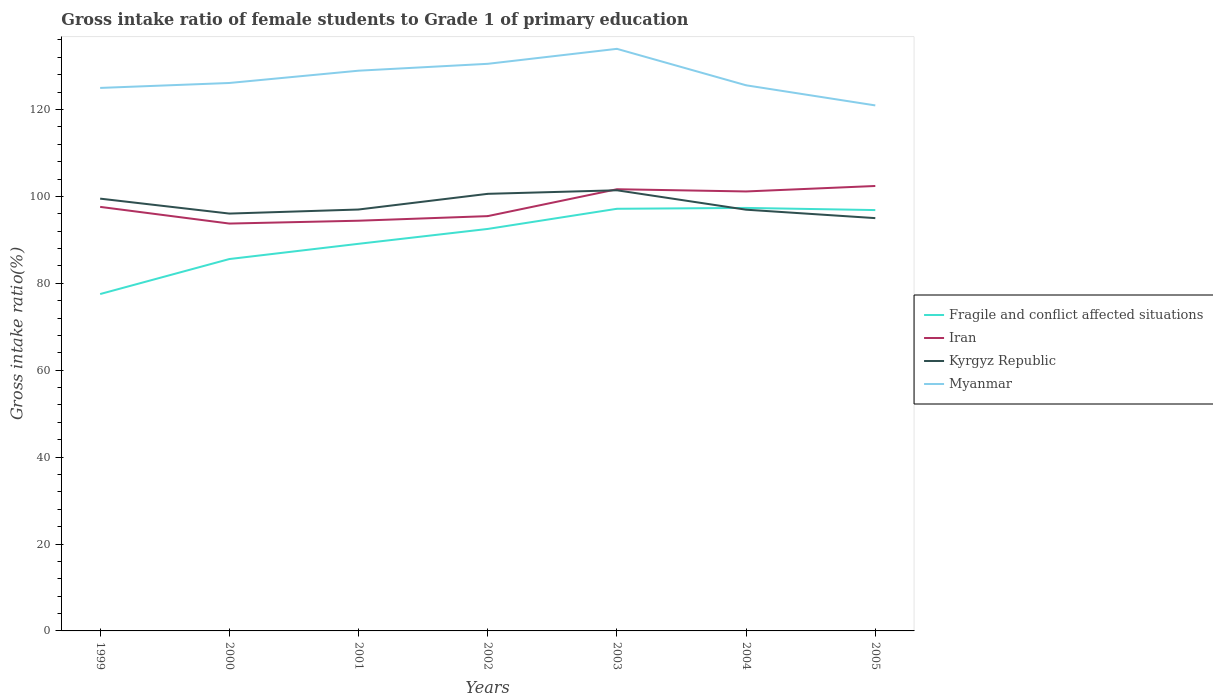Does the line corresponding to Fragile and conflict affected situations intersect with the line corresponding to Kyrgyz Republic?
Keep it short and to the point. Yes. Across all years, what is the maximum gross intake ratio in Kyrgyz Republic?
Offer a very short reply. 95. What is the total gross intake ratio in Iran in the graph?
Give a very brief answer. -1.06. What is the difference between the highest and the second highest gross intake ratio in Fragile and conflict affected situations?
Your answer should be very brief. 19.82. What is the difference between the highest and the lowest gross intake ratio in Kyrgyz Republic?
Your answer should be very brief. 3. How many lines are there?
Your answer should be very brief. 4. What is the difference between two consecutive major ticks on the Y-axis?
Make the answer very short. 20. Are the values on the major ticks of Y-axis written in scientific E-notation?
Give a very brief answer. No. Does the graph contain any zero values?
Your response must be concise. No. Does the graph contain grids?
Offer a terse response. No. What is the title of the graph?
Your answer should be compact. Gross intake ratio of female students to Grade 1 of primary education. What is the label or title of the Y-axis?
Keep it short and to the point. Gross intake ratio(%). What is the Gross intake ratio(%) of Fragile and conflict affected situations in 1999?
Provide a short and direct response. 77.53. What is the Gross intake ratio(%) of Iran in 1999?
Ensure brevity in your answer.  97.59. What is the Gross intake ratio(%) of Kyrgyz Republic in 1999?
Provide a succinct answer. 99.49. What is the Gross intake ratio(%) in Myanmar in 1999?
Offer a very short reply. 124.97. What is the Gross intake ratio(%) in Fragile and conflict affected situations in 2000?
Your answer should be compact. 85.58. What is the Gross intake ratio(%) of Iran in 2000?
Make the answer very short. 93.75. What is the Gross intake ratio(%) of Kyrgyz Republic in 2000?
Offer a very short reply. 96.05. What is the Gross intake ratio(%) in Myanmar in 2000?
Your response must be concise. 126.11. What is the Gross intake ratio(%) in Fragile and conflict affected situations in 2001?
Provide a short and direct response. 89.09. What is the Gross intake ratio(%) in Iran in 2001?
Offer a very short reply. 94.41. What is the Gross intake ratio(%) of Kyrgyz Republic in 2001?
Offer a very short reply. 96.98. What is the Gross intake ratio(%) of Myanmar in 2001?
Ensure brevity in your answer.  128.93. What is the Gross intake ratio(%) in Fragile and conflict affected situations in 2002?
Offer a very short reply. 92.51. What is the Gross intake ratio(%) of Iran in 2002?
Your answer should be very brief. 95.46. What is the Gross intake ratio(%) in Kyrgyz Republic in 2002?
Your response must be concise. 100.59. What is the Gross intake ratio(%) in Myanmar in 2002?
Provide a succinct answer. 130.52. What is the Gross intake ratio(%) of Fragile and conflict affected situations in 2003?
Your answer should be very brief. 97.15. What is the Gross intake ratio(%) of Iran in 2003?
Your response must be concise. 101.65. What is the Gross intake ratio(%) of Kyrgyz Republic in 2003?
Your answer should be compact. 101.41. What is the Gross intake ratio(%) in Myanmar in 2003?
Make the answer very short. 133.96. What is the Gross intake ratio(%) of Fragile and conflict affected situations in 2004?
Ensure brevity in your answer.  97.35. What is the Gross intake ratio(%) of Iran in 2004?
Provide a succinct answer. 101.14. What is the Gross intake ratio(%) of Kyrgyz Republic in 2004?
Offer a terse response. 96.94. What is the Gross intake ratio(%) of Myanmar in 2004?
Keep it short and to the point. 125.57. What is the Gross intake ratio(%) in Fragile and conflict affected situations in 2005?
Your answer should be very brief. 96.86. What is the Gross intake ratio(%) in Iran in 2005?
Provide a short and direct response. 102.4. What is the Gross intake ratio(%) in Kyrgyz Republic in 2005?
Ensure brevity in your answer.  95. What is the Gross intake ratio(%) of Myanmar in 2005?
Offer a terse response. 120.94. Across all years, what is the maximum Gross intake ratio(%) of Fragile and conflict affected situations?
Ensure brevity in your answer.  97.35. Across all years, what is the maximum Gross intake ratio(%) in Iran?
Provide a short and direct response. 102.4. Across all years, what is the maximum Gross intake ratio(%) of Kyrgyz Republic?
Offer a very short reply. 101.41. Across all years, what is the maximum Gross intake ratio(%) in Myanmar?
Give a very brief answer. 133.96. Across all years, what is the minimum Gross intake ratio(%) of Fragile and conflict affected situations?
Give a very brief answer. 77.53. Across all years, what is the minimum Gross intake ratio(%) in Iran?
Ensure brevity in your answer.  93.75. Across all years, what is the minimum Gross intake ratio(%) in Kyrgyz Republic?
Your answer should be compact. 95. Across all years, what is the minimum Gross intake ratio(%) in Myanmar?
Give a very brief answer. 120.94. What is the total Gross intake ratio(%) of Fragile and conflict affected situations in the graph?
Your answer should be compact. 636.08. What is the total Gross intake ratio(%) of Iran in the graph?
Give a very brief answer. 686.4. What is the total Gross intake ratio(%) of Kyrgyz Republic in the graph?
Keep it short and to the point. 686.47. What is the total Gross intake ratio(%) in Myanmar in the graph?
Make the answer very short. 890.99. What is the difference between the Gross intake ratio(%) in Fragile and conflict affected situations in 1999 and that in 2000?
Your response must be concise. -8.05. What is the difference between the Gross intake ratio(%) of Iran in 1999 and that in 2000?
Provide a succinct answer. 3.84. What is the difference between the Gross intake ratio(%) of Kyrgyz Republic in 1999 and that in 2000?
Your answer should be compact. 3.44. What is the difference between the Gross intake ratio(%) in Myanmar in 1999 and that in 2000?
Give a very brief answer. -1.14. What is the difference between the Gross intake ratio(%) in Fragile and conflict affected situations in 1999 and that in 2001?
Your answer should be compact. -11.56. What is the difference between the Gross intake ratio(%) of Iran in 1999 and that in 2001?
Your answer should be very brief. 3.18. What is the difference between the Gross intake ratio(%) in Kyrgyz Republic in 1999 and that in 2001?
Offer a terse response. 2.5. What is the difference between the Gross intake ratio(%) of Myanmar in 1999 and that in 2001?
Your answer should be very brief. -3.97. What is the difference between the Gross intake ratio(%) in Fragile and conflict affected situations in 1999 and that in 2002?
Your answer should be compact. -14.98. What is the difference between the Gross intake ratio(%) of Iran in 1999 and that in 2002?
Provide a short and direct response. 2.12. What is the difference between the Gross intake ratio(%) in Kyrgyz Republic in 1999 and that in 2002?
Provide a succinct answer. -1.11. What is the difference between the Gross intake ratio(%) in Myanmar in 1999 and that in 2002?
Make the answer very short. -5.55. What is the difference between the Gross intake ratio(%) of Fragile and conflict affected situations in 1999 and that in 2003?
Your response must be concise. -19.62. What is the difference between the Gross intake ratio(%) in Iran in 1999 and that in 2003?
Offer a terse response. -4.06. What is the difference between the Gross intake ratio(%) of Kyrgyz Republic in 1999 and that in 2003?
Your response must be concise. -1.92. What is the difference between the Gross intake ratio(%) in Myanmar in 1999 and that in 2003?
Your answer should be compact. -9. What is the difference between the Gross intake ratio(%) of Fragile and conflict affected situations in 1999 and that in 2004?
Give a very brief answer. -19.82. What is the difference between the Gross intake ratio(%) of Iran in 1999 and that in 2004?
Offer a very short reply. -3.55. What is the difference between the Gross intake ratio(%) in Kyrgyz Republic in 1999 and that in 2004?
Ensure brevity in your answer.  2.54. What is the difference between the Gross intake ratio(%) in Myanmar in 1999 and that in 2004?
Your response must be concise. -0.61. What is the difference between the Gross intake ratio(%) of Fragile and conflict affected situations in 1999 and that in 2005?
Offer a terse response. -19.32. What is the difference between the Gross intake ratio(%) of Iran in 1999 and that in 2005?
Ensure brevity in your answer.  -4.81. What is the difference between the Gross intake ratio(%) in Kyrgyz Republic in 1999 and that in 2005?
Give a very brief answer. 4.48. What is the difference between the Gross intake ratio(%) in Myanmar in 1999 and that in 2005?
Provide a short and direct response. 4.02. What is the difference between the Gross intake ratio(%) of Fragile and conflict affected situations in 2000 and that in 2001?
Give a very brief answer. -3.51. What is the difference between the Gross intake ratio(%) in Iran in 2000 and that in 2001?
Your answer should be very brief. -0.65. What is the difference between the Gross intake ratio(%) in Kyrgyz Republic in 2000 and that in 2001?
Your response must be concise. -0.93. What is the difference between the Gross intake ratio(%) of Myanmar in 2000 and that in 2001?
Provide a succinct answer. -2.83. What is the difference between the Gross intake ratio(%) of Fragile and conflict affected situations in 2000 and that in 2002?
Your response must be concise. -6.93. What is the difference between the Gross intake ratio(%) of Iran in 2000 and that in 2002?
Give a very brief answer. -1.71. What is the difference between the Gross intake ratio(%) of Kyrgyz Republic in 2000 and that in 2002?
Keep it short and to the point. -4.54. What is the difference between the Gross intake ratio(%) of Myanmar in 2000 and that in 2002?
Offer a very short reply. -4.41. What is the difference between the Gross intake ratio(%) in Fragile and conflict affected situations in 2000 and that in 2003?
Your answer should be very brief. -11.57. What is the difference between the Gross intake ratio(%) in Iran in 2000 and that in 2003?
Provide a succinct answer. -7.9. What is the difference between the Gross intake ratio(%) in Kyrgyz Republic in 2000 and that in 2003?
Offer a very short reply. -5.36. What is the difference between the Gross intake ratio(%) of Myanmar in 2000 and that in 2003?
Give a very brief answer. -7.86. What is the difference between the Gross intake ratio(%) of Fragile and conflict affected situations in 2000 and that in 2004?
Ensure brevity in your answer.  -11.77. What is the difference between the Gross intake ratio(%) of Iran in 2000 and that in 2004?
Offer a very short reply. -7.39. What is the difference between the Gross intake ratio(%) in Kyrgyz Republic in 2000 and that in 2004?
Make the answer very short. -0.89. What is the difference between the Gross intake ratio(%) in Myanmar in 2000 and that in 2004?
Provide a short and direct response. 0.53. What is the difference between the Gross intake ratio(%) in Fragile and conflict affected situations in 2000 and that in 2005?
Your response must be concise. -11.27. What is the difference between the Gross intake ratio(%) of Iran in 2000 and that in 2005?
Offer a very short reply. -8.65. What is the difference between the Gross intake ratio(%) in Kyrgyz Republic in 2000 and that in 2005?
Your answer should be very brief. 1.05. What is the difference between the Gross intake ratio(%) of Myanmar in 2000 and that in 2005?
Offer a terse response. 5.16. What is the difference between the Gross intake ratio(%) in Fragile and conflict affected situations in 2001 and that in 2002?
Offer a very short reply. -3.42. What is the difference between the Gross intake ratio(%) in Iran in 2001 and that in 2002?
Offer a terse response. -1.06. What is the difference between the Gross intake ratio(%) in Kyrgyz Republic in 2001 and that in 2002?
Make the answer very short. -3.61. What is the difference between the Gross intake ratio(%) of Myanmar in 2001 and that in 2002?
Offer a terse response. -1.58. What is the difference between the Gross intake ratio(%) in Fragile and conflict affected situations in 2001 and that in 2003?
Ensure brevity in your answer.  -8.06. What is the difference between the Gross intake ratio(%) of Iran in 2001 and that in 2003?
Your answer should be very brief. -7.24. What is the difference between the Gross intake ratio(%) of Kyrgyz Republic in 2001 and that in 2003?
Keep it short and to the point. -4.43. What is the difference between the Gross intake ratio(%) of Myanmar in 2001 and that in 2003?
Offer a very short reply. -5.03. What is the difference between the Gross intake ratio(%) in Fragile and conflict affected situations in 2001 and that in 2004?
Your answer should be very brief. -8.26. What is the difference between the Gross intake ratio(%) of Iran in 2001 and that in 2004?
Ensure brevity in your answer.  -6.74. What is the difference between the Gross intake ratio(%) of Kyrgyz Republic in 2001 and that in 2004?
Your response must be concise. 0.04. What is the difference between the Gross intake ratio(%) in Myanmar in 2001 and that in 2004?
Provide a short and direct response. 3.36. What is the difference between the Gross intake ratio(%) of Fragile and conflict affected situations in 2001 and that in 2005?
Your answer should be very brief. -7.76. What is the difference between the Gross intake ratio(%) of Iran in 2001 and that in 2005?
Ensure brevity in your answer.  -8. What is the difference between the Gross intake ratio(%) in Kyrgyz Republic in 2001 and that in 2005?
Your answer should be compact. 1.98. What is the difference between the Gross intake ratio(%) of Myanmar in 2001 and that in 2005?
Provide a succinct answer. 7.99. What is the difference between the Gross intake ratio(%) in Fragile and conflict affected situations in 2002 and that in 2003?
Your answer should be very brief. -4.64. What is the difference between the Gross intake ratio(%) of Iran in 2002 and that in 2003?
Offer a terse response. -6.19. What is the difference between the Gross intake ratio(%) in Kyrgyz Republic in 2002 and that in 2003?
Your response must be concise. -0.82. What is the difference between the Gross intake ratio(%) in Myanmar in 2002 and that in 2003?
Ensure brevity in your answer.  -3.45. What is the difference between the Gross intake ratio(%) in Fragile and conflict affected situations in 2002 and that in 2004?
Keep it short and to the point. -4.84. What is the difference between the Gross intake ratio(%) of Iran in 2002 and that in 2004?
Ensure brevity in your answer.  -5.68. What is the difference between the Gross intake ratio(%) of Kyrgyz Republic in 2002 and that in 2004?
Your answer should be compact. 3.65. What is the difference between the Gross intake ratio(%) in Myanmar in 2002 and that in 2004?
Provide a succinct answer. 4.94. What is the difference between the Gross intake ratio(%) of Fragile and conflict affected situations in 2002 and that in 2005?
Your answer should be compact. -4.34. What is the difference between the Gross intake ratio(%) of Iran in 2002 and that in 2005?
Ensure brevity in your answer.  -6.94. What is the difference between the Gross intake ratio(%) in Kyrgyz Republic in 2002 and that in 2005?
Offer a very short reply. 5.59. What is the difference between the Gross intake ratio(%) of Myanmar in 2002 and that in 2005?
Provide a succinct answer. 9.57. What is the difference between the Gross intake ratio(%) in Fragile and conflict affected situations in 2003 and that in 2004?
Give a very brief answer. -0.2. What is the difference between the Gross intake ratio(%) in Iran in 2003 and that in 2004?
Make the answer very short. 0.51. What is the difference between the Gross intake ratio(%) of Kyrgyz Republic in 2003 and that in 2004?
Make the answer very short. 4.47. What is the difference between the Gross intake ratio(%) of Myanmar in 2003 and that in 2004?
Keep it short and to the point. 8.39. What is the difference between the Gross intake ratio(%) of Fragile and conflict affected situations in 2003 and that in 2005?
Provide a succinct answer. 0.3. What is the difference between the Gross intake ratio(%) in Iran in 2003 and that in 2005?
Your answer should be very brief. -0.75. What is the difference between the Gross intake ratio(%) of Kyrgyz Republic in 2003 and that in 2005?
Your answer should be compact. 6.41. What is the difference between the Gross intake ratio(%) in Myanmar in 2003 and that in 2005?
Give a very brief answer. 13.02. What is the difference between the Gross intake ratio(%) in Fragile and conflict affected situations in 2004 and that in 2005?
Your answer should be compact. 0.49. What is the difference between the Gross intake ratio(%) of Iran in 2004 and that in 2005?
Your answer should be compact. -1.26. What is the difference between the Gross intake ratio(%) of Kyrgyz Republic in 2004 and that in 2005?
Provide a short and direct response. 1.94. What is the difference between the Gross intake ratio(%) of Myanmar in 2004 and that in 2005?
Keep it short and to the point. 4.63. What is the difference between the Gross intake ratio(%) in Fragile and conflict affected situations in 1999 and the Gross intake ratio(%) in Iran in 2000?
Your answer should be very brief. -16.22. What is the difference between the Gross intake ratio(%) of Fragile and conflict affected situations in 1999 and the Gross intake ratio(%) of Kyrgyz Republic in 2000?
Your answer should be very brief. -18.52. What is the difference between the Gross intake ratio(%) in Fragile and conflict affected situations in 1999 and the Gross intake ratio(%) in Myanmar in 2000?
Give a very brief answer. -48.57. What is the difference between the Gross intake ratio(%) of Iran in 1999 and the Gross intake ratio(%) of Kyrgyz Republic in 2000?
Provide a succinct answer. 1.54. What is the difference between the Gross intake ratio(%) in Iran in 1999 and the Gross intake ratio(%) in Myanmar in 2000?
Provide a succinct answer. -28.52. What is the difference between the Gross intake ratio(%) of Kyrgyz Republic in 1999 and the Gross intake ratio(%) of Myanmar in 2000?
Keep it short and to the point. -26.62. What is the difference between the Gross intake ratio(%) of Fragile and conflict affected situations in 1999 and the Gross intake ratio(%) of Iran in 2001?
Provide a short and direct response. -16.87. What is the difference between the Gross intake ratio(%) in Fragile and conflict affected situations in 1999 and the Gross intake ratio(%) in Kyrgyz Republic in 2001?
Keep it short and to the point. -19.45. What is the difference between the Gross intake ratio(%) in Fragile and conflict affected situations in 1999 and the Gross intake ratio(%) in Myanmar in 2001?
Make the answer very short. -51.4. What is the difference between the Gross intake ratio(%) in Iran in 1999 and the Gross intake ratio(%) in Kyrgyz Republic in 2001?
Provide a succinct answer. 0.6. What is the difference between the Gross intake ratio(%) of Iran in 1999 and the Gross intake ratio(%) of Myanmar in 2001?
Your answer should be very brief. -31.34. What is the difference between the Gross intake ratio(%) of Kyrgyz Republic in 1999 and the Gross intake ratio(%) of Myanmar in 2001?
Provide a short and direct response. -29.45. What is the difference between the Gross intake ratio(%) of Fragile and conflict affected situations in 1999 and the Gross intake ratio(%) of Iran in 2002?
Make the answer very short. -17.93. What is the difference between the Gross intake ratio(%) of Fragile and conflict affected situations in 1999 and the Gross intake ratio(%) of Kyrgyz Republic in 2002?
Your answer should be compact. -23.06. What is the difference between the Gross intake ratio(%) of Fragile and conflict affected situations in 1999 and the Gross intake ratio(%) of Myanmar in 2002?
Provide a succinct answer. -52.98. What is the difference between the Gross intake ratio(%) in Iran in 1999 and the Gross intake ratio(%) in Kyrgyz Republic in 2002?
Your response must be concise. -3. What is the difference between the Gross intake ratio(%) in Iran in 1999 and the Gross intake ratio(%) in Myanmar in 2002?
Provide a succinct answer. -32.93. What is the difference between the Gross intake ratio(%) of Kyrgyz Republic in 1999 and the Gross intake ratio(%) of Myanmar in 2002?
Provide a short and direct response. -31.03. What is the difference between the Gross intake ratio(%) in Fragile and conflict affected situations in 1999 and the Gross intake ratio(%) in Iran in 2003?
Keep it short and to the point. -24.12. What is the difference between the Gross intake ratio(%) in Fragile and conflict affected situations in 1999 and the Gross intake ratio(%) in Kyrgyz Republic in 2003?
Make the answer very short. -23.88. What is the difference between the Gross intake ratio(%) of Fragile and conflict affected situations in 1999 and the Gross intake ratio(%) of Myanmar in 2003?
Offer a terse response. -56.43. What is the difference between the Gross intake ratio(%) of Iran in 1999 and the Gross intake ratio(%) of Kyrgyz Republic in 2003?
Provide a short and direct response. -3.82. What is the difference between the Gross intake ratio(%) in Iran in 1999 and the Gross intake ratio(%) in Myanmar in 2003?
Give a very brief answer. -36.37. What is the difference between the Gross intake ratio(%) of Kyrgyz Republic in 1999 and the Gross intake ratio(%) of Myanmar in 2003?
Ensure brevity in your answer.  -34.48. What is the difference between the Gross intake ratio(%) in Fragile and conflict affected situations in 1999 and the Gross intake ratio(%) in Iran in 2004?
Make the answer very short. -23.61. What is the difference between the Gross intake ratio(%) of Fragile and conflict affected situations in 1999 and the Gross intake ratio(%) of Kyrgyz Republic in 2004?
Provide a short and direct response. -19.41. What is the difference between the Gross intake ratio(%) of Fragile and conflict affected situations in 1999 and the Gross intake ratio(%) of Myanmar in 2004?
Your response must be concise. -48.04. What is the difference between the Gross intake ratio(%) of Iran in 1999 and the Gross intake ratio(%) of Kyrgyz Republic in 2004?
Ensure brevity in your answer.  0.65. What is the difference between the Gross intake ratio(%) in Iran in 1999 and the Gross intake ratio(%) in Myanmar in 2004?
Offer a terse response. -27.98. What is the difference between the Gross intake ratio(%) of Kyrgyz Republic in 1999 and the Gross intake ratio(%) of Myanmar in 2004?
Your response must be concise. -26.09. What is the difference between the Gross intake ratio(%) of Fragile and conflict affected situations in 1999 and the Gross intake ratio(%) of Iran in 2005?
Your response must be concise. -24.87. What is the difference between the Gross intake ratio(%) of Fragile and conflict affected situations in 1999 and the Gross intake ratio(%) of Kyrgyz Republic in 2005?
Your answer should be very brief. -17.47. What is the difference between the Gross intake ratio(%) in Fragile and conflict affected situations in 1999 and the Gross intake ratio(%) in Myanmar in 2005?
Keep it short and to the point. -43.41. What is the difference between the Gross intake ratio(%) in Iran in 1999 and the Gross intake ratio(%) in Kyrgyz Republic in 2005?
Your answer should be very brief. 2.59. What is the difference between the Gross intake ratio(%) in Iran in 1999 and the Gross intake ratio(%) in Myanmar in 2005?
Offer a very short reply. -23.35. What is the difference between the Gross intake ratio(%) of Kyrgyz Republic in 1999 and the Gross intake ratio(%) of Myanmar in 2005?
Your answer should be compact. -21.46. What is the difference between the Gross intake ratio(%) in Fragile and conflict affected situations in 2000 and the Gross intake ratio(%) in Iran in 2001?
Give a very brief answer. -8.82. What is the difference between the Gross intake ratio(%) of Fragile and conflict affected situations in 2000 and the Gross intake ratio(%) of Kyrgyz Republic in 2001?
Your answer should be very brief. -11.4. What is the difference between the Gross intake ratio(%) of Fragile and conflict affected situations in 2000 and the Gross intake ratio(%) of Myanmar in 2001?
Keep it short and to the point. -43.35. What is the difference between the Gross intake ratio(%) in Iran in 2000 and the Gross intake ratio(%) in Kyrgyz Republic in 2001?
Give a very brief answer. -3.23. What is the difference between the Gross intake ratio(%) of Iran in 2000 and the Gross intake ratio(%) of Myanmar in 2001?
Make the answer very short. -35.18. What is the difference between the Gross intake ratio(%) of Kyrgyz Republic in 2000 and the Gross intake ratio(%) of Myanmar in 2001?
Make the answer very short. -32.88. What is the difference between the Gross intake ratio(%) in Fragile and conflict affected situations in 2000 and the Gross intake ratio(%) in Iran in 2002?
Offer a very short reply. -9.88. What is the difference between the Gross intake ratio(%) of Fragile and conflict affected situations in 2000 and the Gross intake ratio(%) of Kyrgyz Republic in 2002?
Offer a very short reply. -15.01. What is the difference between the Gross intake ratio(%) of Fragile and conflict affected situations in 2000 and the Gross intake ratio(%) of Myanmar in 2002?
Your answer should be compact. -44.93. What is the difference between the Gross intake ratio(%) in Iran in 2000 and the Gross intake ratio(%) in Kyrgyz Republic in 2002?
Your answer should be compact. -6.84. What is the difference between the Gross intake ratio(%) of Iran in 2000 and the Gross intake ratio(%) of Myanmar in 2002?
Keep it short and to the point. -36.76. What is the difference between the Gross intake ratio(%) of Kyrgyz Republic in 2000 and the Gross intake ratio(%) of Myanmar in 2002?
Make the answer very short. -34.47. What is the difference between the Gross intake ratio(%) of Fragile and conflict affected situations in 2000 and the Gross intake ratio(%) of Iran in 2003?
Your answer should be compact. -16.07. What is the difference between the Gross intake ratio(%) in Fragile and conflict affected situations in 2000 and the Gross intake ratio(%) in Kyrgyz Republic in 2003?
Provide a short and direct response. -15.83. What is the difference between the Gross intake ratio(%) in Fragile and conflict affected situations in 2000 and the Gross intake ratio(%) in Myanmar in 2003?
Offer a terse response. -48.38. What is the difference between the Gross intake ratio(%) in Iran in 2000 and the Gross intake ratio(%) in Kyrgyz Republic in 2003?
Give a very brief answer. -7.66. What is the difference between the Gross intake ratio(%) in Iran in 2000 and the Gross intake ratio(%) in Myanmar in 2003?
Make the answer very short. -40.21. What is the difference between the Gross intake ratio(%) of Kyrgyz Republic in 2000 and the Gross intake ratio(%) of Myanmar in 2003?
Keep it short and to the point. -37.91. What is the difference between the Gross intake ratio(%) of Fragile and conflict affected situations in 2000 and the Gross intake ratio(%) of Iran in 2004?
Your response must be concise. -15.56. What is the difference between the Gross intake ratio(%) in Fragile and conflict affected situations in 2000 and the Gross intake ratio(%) in Kyrgyz Republic in 2004?
Keep it short and to the point. -11.36. What is the difference between the Gross intake ratio(%) in Fragile and conflict affected situations in 2000 and the Gross intake ratio(%) in Myanmar in 2004?
Ensure brevity in your answer.  -39.99. What is the difference between the Gross intake ratio(%) of Iran in 2000 and the Gross intake ratio(%) of Kyrgyz Republic in 2004?
Keep it short and to the point. -3.19. What is the difference between the Gross intake ratio(%) of Iran in 2000 and the Gross intake ratio(%) of Myanmar in 2004?
Offer a very short reply. -31.82. What is the difference between the Gross intake ratio(%) in Kyrgyz Republic in 2000 and the Gross intake ratio(%) in Myanmar in 2004?
Your response must be concise. -29.52. What is the difference between the Gross intake ratio(%) in Fragile and conflict affected situations in 2000 and the Gross intake ratio(%) in Iran in 2005?
Make the answer very short. -16.82. What is the difference between the Gross intake ratio(%) in Fragile and conflict affected situations in 2000 and the Gross intake ratio(%) in Kyrgyz Republic in 2005?
Your answer should be very brief. -9.42. What is the difference between the Gross intake ratio(%) of Fragile and conflict affected situations in 2000 and the Gross intake ratio(%) of Myanmar in 2005?
Your answer should be very brief. -35.36. What is the difference between the Gross intake ratio(%) of Iran in 2000 and the Gross intake ratio(%) of Kyrgyz Republic in 2005?
Provide a short and direct response. -1.25. What is the difference between the Gross intake ratio(%) of Iran in 2000 and the Gross intake ratio(%) of Myanmar in 2005?
Your response must be concise. -27.19. What is the difference between the Gross intake ratio(%) of Kyrgyz Republic in 2000 and the Gross intake ratio(%) of Myanmar in 2005?
Offer a terse response. -24.89. What is the difference between the Gross intake ratio(%) in Fragile and conflict affected situations in 2001 and the Gross intake ratio(%) in Iran in 2002?
Provide a short and direct response. -6.37. What is the difference between the Gross intake ratio(%) of Fragile and conflict affected situations in 2001 and the Gross intake ratio(%) of Kyrgyz Republic in 2002?
Offer a terse response. -11.5. What is the difference between the Gross intake ratio(%) in Fragile and conflict affected situations in 2001 and the Gross intake ratio(%) in Myanmar in 2002?
Give a very brief answer. -41.42. What is the difference between the Gross intake ratio(%) of Iran in 2001 and the Gross intake ratio(%) of Kyrgyz Republic in 2002?
Make the answer very short. -6.19. What is the difference between the Gross intake ratio(%) in Iran in 2001 and the Gross intake ratio(%) in Myanmar in 2002?
Keep it short and to the point. -36.11. What is the difference between the Gross intake ratio(%) in Kyrgyz Republic in 2001 and the Gross intake ratio(%) in Myanmar in 2002?
Make the answer very short. -33.53. What is the difference between the Gross intake ratio(%) in Fragile and conflict affected situations in 2001 and the Gross intake ratio(%) in Iran in 2003?
Give a very brief answer. -12.56. What is the difference between the Gross intake ratio(%) in Fragile and conflict affected situations in 2001 and the Gross intake ratio(%) in Kyrgyz Republic in 2003?
Your answer should be very brief. -12.32. What is the difference between the Gross intake ratio(%) in Fragile and conflict affected situations in 2001 and the Gross intake ratio(%) in Myanmar in 2003?
Your answer should be very brief. -44.87. What is the difference between the Gross intake ratio(%) of Iran in 2001 and the Gross intake ratio(%) of Kyrgyz Republic in 2003?
Make the answer very short. -7.01. What is the difference between the Gross intake ratio(%) in Iran in 2001 and the Gross intake ratio(%) in Myanmar in 2003?
Offer a terse response. -39.56. What is the difference between the Gross intake ratio(%) of Kyrgyz Republic in 2001 and the Gross intake ratio(%) of Myanmar in 2003?
Make the answer very short. -36.98. What is the difference between the Gross intake ratio(%) of Fragile and conflict affected situations in 2001 and the Gross intake ratio(%) of Iran in 2004?
Your answer should be very brief. -12.05. What is the difference between the Gross intake ratio(%) in Fragile and conflict affected situations in 2001 and the Gross intake ratio(%) in Kyrgyz Republic in 2004?
Offer a very short reply. -7.85. What is the difference between the Gross intake ratio(%) of Fragile and conflict affected situations in 2001 and the Gross intake ratio(%) of Myanmar in 2004?
Make the answer very short. -36.48. What is the difference between the Gross intake ratio(%) in Iran in 2001 and the Gross intake ratio(%) in Kyrgyz Republic in 2004?
Give a very brief answer. -2.54. What is the difference between the Gross intake ratio(%) in Iran in 2001 and the Gross intake ratio(%) in Myanmar in 2004?
Provide a succinct answer. -31.17. What is the difference between the Gross intake ratio(%) in Kyrgyz Republic in 2001 and the Gross intake ratio(%) in Myanmar in 2004?
Offer a terse response. -28.59. What is the difference between the Gross intake ratio(%) in Fragile and conflict affected situations in 2001 and the Gross intake ratio(%) in Iran in 2005?
Make the answer very short. -13.31. What is the difference between the Gross intake ratio(%) in Fragile and conflict affected situations in 2001 and the Gross intake ratio(%) in Kyrgyz Republic in 2005?
Your answer should be compact. -5.91. What is the difference between the Gross intake ratio(%) of Fragile and conflict affected situations in 2001 and the Gross intake ratio(%) of Myanmar in 2005?
Make the answer very short. -31.85. What is the difference between the Gross intake ratio(%) in Iran in 2001 and the Gross intake ratio(%) in Kyrgyz Republic in 2005?
Make the answer very short. -0.6. What is the difference between the Gross intake ratio(%) in Iran in 2001 and the Gross intake ratio(%) in Myanmar in 2005?
Provide a short and direct response. -26.54. What is the difference between the Gross intake ratio(%) in Kyrgyz Republic in 2001 and the Gross intake ratio(%) in Myanmar in 2005?
Give a very brief answer. -23.96. What is the difference between the Gross intake ratio(%) of Fragile and conflict affected situations in 2002 and the Gross intake ratio(%) of Iran in 2003?
Your answer should be very brief. -9.14. What is the difference between the Gross intake ratio(%) of Fragile and conflict affected situations in 2002 and the Gross intake ratio(%) of Kyrgyz Republic in 2003?
Offer a terse response. -8.9. What is the difference between the Gross intake ratio(%) in Fragile and conflict affected situations in 2002 and the Gross intake ratio(%) in Myanmar in 2003?
Provide a short and direct response. -41.45. What is the difference between the Gross intake ratio(%) in Iran in 2002 and the Gross intake ratio(%) in Kyrgyz Republic in 2003?
Keep it short and to the point. -5.95. What is the difference between the Gross intake ratio(%) of Iran in 2002 and the Gross intake ratio(%) of Myanmar in 2003?
Ensure brevity in your answer.  -38.5. What is the difference between the Gross intake ratio(%) of Kyrgyz Republic in 2002 and the Gross intake ratio(%) of Myanmar in 2003?
Provide a short and direct response. -33.37. What is the difference between the Gross intake ratio(%) in Fragile and conflict affected situations in 2002 and the Gross intake ratio(%) in Iran in 2004?
Give a very brief answer. -8.63. What is the difference between the Gross intake ratio(%) of Fragile and conflict affected situations in 2002 and the Gross intake ratio(%) of Kyrgyz Republic in 2004?
Keep it short and to the point. -4.43. What is the difference between the Gross intake ratio(%) in Fragile and conflict affected situations in 2002 and the Gross intake ratio(%) in Myanmar in 2004?
Keep it short and to the point. -33.06. What is the difference between the Gross intake ratio(%) in Iran in 2002 and the Gross intake ratio(%) in Kyrgyz Republic in 2004?
Your answer should be compact. -1.48. What is the difference between the Gross intake ratio(%) of Iran in 2002 and the Gross intake ratio(%) of Myanmar in 2004?
Provide a succinct answer. -30.11. What is the difference between the Gross intake ratio(%) of Kyrgyz Republic in 2002 and the Gross intake ratio(%) of Myanmar in 2004?
Keep it short and to the point. -24.98. What is the difference between the Gross intake ratio(%) in Fragile and conflict affected situations in 2002 and the Gross intake ratio(%) in Iran in 2005?
Provide a succinct answer. -9.89. What is the difference between the Gross intake ratio(%) of Fragile and conflict affected situations in 2002 and the Gross intake ratio(%) of Kyrgyz Republic in 2005?
Give a very brief answer. -2.49. What is the difference between the Gross intake ratio(%) of Fragile and conflict affected situations in 2002 and the Gross intake ratio(%) of Myanmar in 2005?
Your answer should be very brief. -28.43. What is the difference between the Gross intake ratio(%) of Iran in 2002 and the Gross intake ratio(%) of Kyrgyz Republic in 2005?
Your answer should be very brief. 0.46. What is the difference between the Gross intake ratio(%) in Iran in 2002 and the Gross intake ratio(%) in Myanmar in 2005?
Ensure brevity in your answer.  -25.48. What is the difference between the Gross intake ratio(%) in Kyrgyz Republic in 2002 and the Gross intake ratio(%) in Myanmar in 2005?
Your response must be concise. -20.35. What is the difference between the Gross intake ratio(%) of Fragile and conflict affected situations in 2003 and the Gross intake ratio(%) of Iran in 2004?
Your response must be concise. -3.99. What is the difference between the Gross intake ratio(%) in Fragile and conflict affected situations in 2003 and the Gross intake ratio(%) in Kyrgyz Republic in 2004?
Provide a succinct answer. 0.21. What is the difference between the Gross intake ratio(%) of Fragile and conflict affected situations in 2003 and the Gross intake ratio(%) of Myanmar in 2004?
Your answer should be compact. -28.42. What is the difference between the Gross intake ratio(%) in Iran in 2003 and the Gross intake ratio(%) in Kyrgyz Republic in 2004?
Make the answer very short. 4.71. What is the difference between the Gross intake ratio(%) in Iran in 2003 and the Gross intake ratio(%) in Myanmar in 2004?
Keep it short and to the point. -23.92. What is the difference between the Gross intake ratio(%) of Kyrgyz Republic in 2003 and the Gross intake ratio(%) of Myanmar in 2004?
Your answer should be very brief. -24.16. What is the difference between the Gross intake ratio(%) in Fragile and conflict affected situations in 2003 and the Gross intake ratio(%) in Iran in 2005?
Make the answer very short. -5.25. What is the difference between the Gross intake ratio(%) of Fragile and conflict affected situations in 2003 and the Gross intake ratio(%) of Kyrgyz Republic in 2005?
Offer a very short reply. 2.15. What is the difference between the Gross intake ratio(%) in Fragile and conflict affected situations in 2003 and the Gross intake ratio(%) in Myanmar in 2005?
Your response must be concise. -23.79. What is the difference between the Gross intake ratio(%) of Iran in 2003 and the Gross intake ratio(%) of Kyrgyz Republic in 2005?
Your response must be concise. 6.65. What is the difference between the Gross intake ratio(%) of Iran in 2003 and the Gross intake ratio(%) of Myanmar in 2005?
Ensure brevity in your answer.  -19.29. What is the difference between the Gross intake ratio(%) in Kyrgyz Republic in 2003 and the Gross intake ratio(%) in Myanmar in 2005?
Offer a terse response. -19.53. What is the difference between the Gross intake ratio(%) in Fragile and conflict affected situations in 2004 and the Gross intake ratio(%) in Iran in 2005?
Your answer should be compact. -5.05. What is the difference between the Gross intake ratio(%) in Fragile and conflict affected situations in 2004 and the Gross intake ratio(%) in Kyrgyz Republic in 2005?
Your answer should be compact. 2.35. What is the difference between the Gross intake ratio(%) in Fragile and conflict affected situations in 2004 and the Gross intake ratio(%) in Myanmar in 2005?
Provide a succinct answer. -23.59. What is the difference between the Gross intake ratio(%) in Iran in 2004 and the Gross intake ratio(%) in Kyrgyz Republic in 2005?
Give a very brief answer. 6.14. What is the difference between the Gross intake ratio(%) of Iran in 2004 and the Gross intake ratio(%) of Myanmar in 2005?
Keep it short and to the point. -19.8. What is the difference between the Gross intake ratio(%) of Kyrgyz Republic in 2004 and the Gross intake ratio(%) of Myanmar in 2005?
Offer a very short reply. -24. What is the average Gross intake ratio(%) in Fragile and conflict affected situations per year?
Offer a very short reply. 90.87. What is the average Gross intake ratio(%) of Iran per year?
Provide a short and direct response. 98.06. What is the average Gross intake ratio(%) of Kyrgyz Republic per year?
Your response must be concise. 98.07. What is the average Gross intake ratio(%) of Myanmar per year?
Provide a short and direct response. 127.28. In the year 1999, what is the difference between the Gross intake ratio(%) in Fragile and conflict affected situations and Gross intake ratio(%) in Iran?
Give a very brief answer. -20.06. In the year 1999, what is the difference between the Gross intake ratio(%) of Fragile and conflict affected situations and Gross intake ratio(%) of Kyrgyz Republic?
Your answer should be compact. -21.95. In the year 1999, what is the difference between the Gross intake ratio(%) in Fragile and conflict affected situations and Gross intake ratio(%) in Myanmar?
Offer a terse response. -47.43. In the year 1999, what is the difference between the Gross intake ratio(%) of Iran and Gross intake ratio(%) of Kyrgyz Republic?
Provide a succinct answer. -1.9. In the year 1999, what is the difference between the Gross intake ratio(%) in Iran and Gross intake ratio(%) in Myanmar?
Keep it short and to the point. -27.38. In the year 1999, what is the difference between the Gross intake ratio(%) in Kyrgyz Republic and Gross intake ratio(%) in Myanmar?
Your answer should be very brief. -25.48. In the year 2000, what is the difference between the Gross intake ratio(%) of Fragile and conflict affected situations and Gross intake ratio(%) of Iran?
Provide a succinct answer. -8.17. In the year 2000, what is the difference between the Gross intake ratio(%) in Fragile and conflict affected situations and Gross intake ratio(%) in Kyrgyz Republic?
Make the answer very short. -10.47. In the year 2000, what is the difference between the Gross intake ratio(%) in Fragile and conflict affected situations and Gross intake ratio(%) in Myanmar?
Keep it short and to the point. -40.52. In the year 2000, what is the difference between the Gross intake ratio(%) of Iran and Gross intake ratio(%) of Kyrgyz Republic?
Your answer should be compact. -2.3. In the year 2000, what is the difference between the Gross intake ratio(%) in Iran and Gross intake ratio(%) in Myanmar?
Your answer should be very brief. -32.35. In the year 2000, what is the difference between the Gross intake ratio(%) in Kyrgyz Republic and Gross intake ratio(%) in Myanmar?
Offer a terse response. -30.05. In the year 2001, what is the difference between the Gross intake ratio(%) in Fragile and conflict affected situations and Gross intake ratio(%) in Iran?
Give a very brief answer. -5.31. In the year 2001, what is the difference between the Gross intake ratio(%) in Fragile and conflict affected situations and Gross intake ratio(%) in Kyrgyz Republic?
Provide a short and direct response. -7.89. In the year 2001, what is the difference between the Gross intake ratio(%) in Fragile and conflict affected situations and Gross intake ratio(%) in Myanmar?
Provide a short and direct response. -39.84. In the year 2001, what is the difference between the Gross intake ratio(%) in Iran and Gross intake ratio(%) in Kyrgyz Republic?
Offer a very short reply. -2.58. In the year 2001, what is the difference between the Gross intake ratio(%) in Iran and Gross intake ratio(%) in Myanmar?
Keep it short and to the point. -34.53. In the year 2001, what is the difference between the Gross intake ratio(%) of Kyrgyz Republic and Gross intake ratio(%) of Myanmar?
Your answer should be very brief. -31.95. In the year 2002, what is the difference between the Gross intake ratio(%) in Fragile and conflict affected situations and Gross intake ratio(%) in Iran?
Make the answer very short. -2.95. In the year 2002, what is the difference between the Gross intake ratio(%) in Fragile and conflict affected situations and Gross intake ratio(%) in Kyrgyz Republic?
Offer a terse response. -8.08. In the year 2002, what is the difference between the Gross intake ratio(%) in Fragile and conflict affected situations and Gross intake ratio(%) in Myanmar?
Give a very brief answer. -38. In the year 2002, what is the difference between the Gross intake ratio(%) in Iran and Gross intake ratio(%) in Kyrgyz Republic?
Your answer should be very brief. -5.13. In the year 2002, what is the difference between the Gross intake ratio(%) in Iran and Gross intake ratio(%) in Myanmar?
Ensure brevity in your answer.  -35.05. In the year 2002, what is the difference between the Gross intake ratio(%) in Kyrgyz Republic and Gross intake ratio(%) in Myanmar?
Keep it short and to the point. -29.92. In the year 2003, what is the difference between the Gross intake ratio(%) in Fragile and conflict affected situations and Gross intake ratio(%) in Iran?
Provide a succinct answer. -4.5. In the year 2003, what is the difference between the Gross intake ratio(%) in Fragile and conflict affected situations and Gross intake ratio(%) in Kyrgyz Republic?
Make the answer very short. -4.26. In the year 2003, what is the difference between the Gross intake ratio(%) in Fragile and conflict affected situations and Gross intake ratio(%) in Myanmar?
Give a very brief answer. -36.81. In the year 2003, what is the difference between the Gross intake ratio(%) of Iran and Gross intake ratio(%) of Kyrgyz Republic?
Your answer should be compact. 0.24. In the year 2003, what is the difference between the Gross intake ratio(%) in Iran and Gross intake ratio(%) in Myanmar?
Make the answer very short. -32.31. In the year 2003, what is the difference between the Gross intake ratio(%) in Kyrgyz Republic and Gross intake ratio(%) in Myanmar?
Provide a succinct answer. -32.55. In the year 2004, what is the difference between the Gross intake ratio(%) in Fragile and conflict affected situations and Gross intake ratio(%) in Iran?
Keep it short and to the point. -3.79. In the year 2004, what is the difference between the Gross intake ratio(%) of Fragile and conflict affected situations and Gross intake ratio(%) of Kyrgyz Republic?
Your answer should be compact. 0.41. In the year 2004, what is the difference between the Gross intake ratio(%) in Fragile and conflict affected situations and Gross intake ratio(%) in Myanmar?
Offer a very short reply. -28.22. In the year 2004, what is the difference between the Gross intake ratio(%) in Iran and Gross intake ratio(%) in Kyrgyz Republic?
Give a very brief answer. 4.2. In the year 2004, what is the difference between the Gross intake ratio(%) of Iran and Gross intake ratio(%) of Myanmar?
Provide a succinct answer. -24.43. In the year 2004, what is the difference between the Gross intake ratio(%) in Kyrgyz Republic and Gross intake ratio(%) in Myanmar?
Keep it short and to the point. -28.63. In the year 2005, what is the difference between the Gross intake ratio(%) of Fragile and conflict affected situations and Gross intake ratio(%) of Iran?
Give a very brief answer. -5.54. In the year 2005, what is the difference between the Gross intake ratio(%) of Fragile and conflict affected situations and Gross intake ratio(%) of Kyrgyz Republic?
Your response must be concise. 1.85. In the year 2005, what is the difference between the Gross intake ratio(%) in Fragile and conflict affected situations and Gross intake ratio(%) in Myanmar?
Make the answer very short. -24.09. In the year 2005, what is the difference between the Gross intake ratio(%) of Iran and Gross intake ratio(%) of Kyrgyz Republic?
Your response must be concise. 7.4. In the year 2005, what is the difference between the Gross intake ratio(%) of Iran and Gross intake ratio(%) of Myanmar?
Provide a short and direct response. -18.54. In the year 2005, what is the difference between the Gross intake ratio(%) of Kyrgyz Republic and Gross intake ratio(%) of Myanmar?
Offer a very short reply. -25.94. What is the ratio of the Gross intake ratio(%) in Fragile and conflict affected situations in 1999 to that in 2000?
Offer a very short reply. 0.91. What is the ratio of the Gross intake ratio(%) in Iran in 1999 to that in 2000?
Provide a short and direct response. 1.04. What is the ratio of the Gross intake ratio(%) of Kyrgyz Republic in 1999 to that in 2000?
Your answer should be very brief. 1.04. What is the ratio of the Gross intake ratio(%) of Fragile and conflict affected situations in 1999 to that in 2001?
Ensure brevity in your answer.  0.87. What is the ratio of the Gross intake ratio(%) in Iran in 1999 to that in 2001?
Give a very brief answer. 1.03. What is the ratio of the Gross intake ratio(%) in Kyrgyz Republic in 1999 to that in 2001?
Give a very brief answer. 1.03. What is the ratio of the Gross intake ratio(%) of Myanmar in 1999 to that in 2001?
Provide a succinct answer. 0.97. What is the ratio of the Gross intake ratio(%) of Fragile and conflict affected situations in 1999 to that in 2002?
Keep it short and to the point. 0.84. What is the ratio of the Gross intake ratio(%) of Iran in 1999 to that in 2002?
Provide a succinct answer. 1.02. What is the ratio of the Gross intake ratio(%) of Myanmar in 1999 to that in 2002?
Your response must be concise. 0.96. What is the ratio of the Gross intake ratio(%) in Fragile and conflict affected situations in 1999 to that in 2003?
Your answer should be very brief. 0.8. What is the ratio of the Gross intake ratio(%) of Iran in 1999 to that in 2003?
Make the answer very short. 0.96. What is the ratio of the Gross intake ratio(%) of Kyrgyz Republic in 1999 to that in 2003?
Provide a succinct answer. 0.98. What is the ratio of the Gross intake ratio(%) in Myanmar in 1999 to that in 2003?
Your response must be concise. 0.93. What is the ratio of the Gross intake ratio(%) in Fragile and conflict affected situations in 1999 to that in 2004?
Provide a short and direct response. 0.8. What is the ratio of the Gross intake ratio(%) of Iran in 1999 to that in 2004?
Offer a terse response. 0.96. What is the ratio of the Gross intake ratio(%) in Kyrgyz Republic in 1999 to that in 2004?
Make the answer very short. 1.03. What is the ratio of the Gross intake ratio(%) in Fragile and conflict affected situations in 1999 to that in 2005?
Offer a very short reply. 0.8. What is the ratio of the Gross intake ratio(%) of Iran in 1999 to that in 2005?
Keep it short and to the point. 0.95. What is the ratio of the Gross intake ratio(%) of Kyrgyz Republic in 1999 to that in 2005?
Provide a succinct answer. 1.05. What is the ratio of the Gross intake ratio(%) of Fragile and conflict affected situations in 2000 to that in 2001?
Ensure brevity in your answer.  0.96. What is the ratio of the Gross intake ratio(%) of Iran in 2000 to that in 2001?
Offer a very short reply. 0.99. What is the ratio of the Gross intake ratio(%) in Myanmar in 2000 to that in 2001?
Give a very brief answer. 0.98. What is the ratio of the Gross intake ratio(%) of Fragile and conflict affected situations in 2000 to that in 2002?
Ensure brevity in your answer.  0.93. What is the ratio of the Gross intake ratio(%) in Iran in 2000 to that in 2002?
Offer a terse response. 0.98. What is the ratio of the Gross intake ratio(%) of Kyrgyz Republic in 2000 to that in 2002?
Offer a very short reply. 0.95. What is the ratio of the Gross intake ratio(%) in Myanmar in 2000 to that in 2002?
Your answer should be very brief. 0.97. What is the ratio of the Gross intake ratio(%) of Fragile and conflict affected situations in 2000 to that in 2003?
Keep it short and to the point. 0.88. What is the ratio of the Gross intake ratio(%) of Iran in 2000 to that in 2003?
Give a very brief answer. 0.92. What is the ratio of the Gross intake ratio(%) in Kyrgyz Republic in 2000 to that in 2003?
Ensure brevity in your answer.  0.95. What is the ratio of the Gross intake ratio(%) in Myanmar in 2000 to that in 2003?
Give a very brief answer. 0.94. What is the ratio of the Gross intake ratio(%) of Fragile and conflict affected situations in 2000 to that in 2004?
Give a very brief answer. 0.88. What is the ratio of the Gross intake ratio(%) of Iran in 2000 to that in 2004?
Provide a short and direct response. 0.93. What is the ratio of the Gross intake ratio(%) in Kyrgyz Republic in 2000 to that in 2004?
Provide a succinct answer. 0.99. What is the ratio of the Gross intake ratio(%) in Fragile and conflict affected situations in 2000 to that in 2005?
Give a very brief answer. 0.88. What is the ratio of the Gross intake ratio(%) of Iran in 2000 to that in 2005?
Your answer should be very brief. 0.92. What is the ratio of the Gross intake ratio(%) of Kyrgyz Republic in 2000 to that in 2005?
Your answer should be very brief. 1.01. What is the ratio of the Gross intake ratio(%) in Myanmar in 2000 to that in 2005?
Your response must be concise. 1.04. What is the ratio of the Gross intake ratio(%) in Iran in 2001 to that in 2002?
Your response must be concise. 0.99. What is the ratio of the Gross intake ratio(%) of Kyrgyz Republic in 2001 to that in 2002?
Provide a succinct answer. 0.96. What is the ratio of the Gross intake ratio(%) of Myanmar in 2001 to that in 2002?
Your answer should be compact. 0.99. What is the ratio of the Gross intake ratio(%) of Fragile and conflict affected situations in 2001 to that in 2003?
Keep it short and to the point. 0.92. What is the ratio of the Gross intake ratio(%) of Iran in 2001 to that in 2003?
Provide a succinct answer. 0.93. What is the ratio of the Gross intake ratio(%) of Kyrgyz Republic in 2001 to that in 2003?
Provide a succinct answer. 0.96. What is the ratio of the Gross intake ratio(%) in Myanmar in 2001 to that in 2003?
Your answer should be very brief. 0.96. What is the ratio of the Gross intake ratio(%) in Fragile and conflict affected situations in 2001 to that in 2004?
Keep it short and to the point. 0.92. What is the ratio of the Gross intake ratio(%) in Iran in 2001 to that in 2004?
Keep it short and to the point. 0.93. What is the ratio of the Gross intake ratio(%) in Kyrgyz Republic in 2001 to that in 2004?
Offer a terse response. 1. What is the ratio of the Gross intake ratio(%) in Myanmar in 2001 to that in 2004?
Provide a succinct answer. 1.03. What is the ratio of the Gross intake ratio(%) in Fragile and conflict affected situations in 2001 to that in 2005?
Make the answer very short. 0.92. What is the ratio of the Gross intake ratio(%) of Iran in 2001 to that in 2005?
Offer a very short reply. 0.92. What is the ratio of the Gross intake ratio(%) in Kyrgyz Republic in 2001 to that in 2005?
Give a very brief answer. 1.02. What is the ratio of the Gross intake ratio(%) in Myanmar in 2001 to that in 2005?
Offer a terse response. 1.07. What is the ratio of the Gross intake ratio(%) in Fragile and conflict affected situations in 2002 to that in 2003?
Offer a very short reply. 0.95. What is the ratio of the Gross intake ratio(%) in Iran in 2002 to that in 2003?
Keep it short and to the point. 0.94. What is the ratio of the Gross intake ratio(%) of Kyrgyz Republic in 2002 to that in 2003?
Make the answer very short. 0.99. What is the ratio of the Gross intake ratio(%) of Myanmar in 2002 to that in 2003?
Make the answer very short. 0.97. What is the ratio of the Gross intake ratio(%) in Fragile and conflict affected situations in 2002 to that in 2004?
Provide a succinct answer. 0.95. What is the ratio of the Gross intake ratio(%) of Iran in 2002 to that in 2004?
Keep it short and to the point. 0.94. What is the ratio of the Gross intake ratio(%) of Kyrgyz Republic in 2002 to that in 2004?
Ensure brevity in your answer.  1.04. What is the ratio of the Gross intake ratio(%) in Myanmar in 2002 to that in 2004?
Provide a succinct answer. 1.04. What is the ratio of the Gross intake ratio(%) in Fragile and conflict affected situations in 2002 to that in 2005?
Your answer should be very brief. 0.96. What is the ratio of the Gross intake ratio(%) of Iran in 2002 to that in 2005?
Provide a succinct answer. 0.93. What is the ratio of the Gross intake ratio(%) of Kyrgyz Republic in 2002 to that in 2005?
Provide a succinct answer. 1.06. What is the ratio of the Gross intake ratio(%) of Myanmar in 2002 to that in 2005?
Your answer should be compact. 1.08. What is the ratio of the Gross intake ratio(%) of Kyrgyz Republic in 2003 to that in 2004?
Offer a terse response. 1.05. What is the ratio of the Gross intake ratio(%) in Myanmar in 2003 to that in 2004?
Ensure brevity in your answer.  1.07. What is the ratio of the Gross intake ratio(%) of Kyrgyz Republic in 2003 to that in 2005?
Your response must be concise. 1.07. What is the ratio of the Gross intake ratio(%) of Myanmar in 2003 to that in 2005?
Offer a very short reply. 1.11. What is the ratio of the Gross intake ratio(%) in Fragile and conflict affected situations in 2004 to that in 2005?
Offer a very short reply. 1.01. What is the ratio of the Gross intake ratio(%) of Kyrgyz Republic in 2004 to that in 2005?
Keep it short and to the point. 1.02. What is the ratio of the Gross intake ratio(%) in Myanmar in 2004 to that in 2005?
Provide a short and direct response. 1.04. What is the difference between the highest and the second highest Gross intake ratio(%) in Fragile and conflict affected situations?
Make the answer very short. 0.2. What is the difference between the highest and the second highest Gross intake ratio(%) in Iran?
Keep it short and to the point. 0.75. What is the difference between the highest and the second highest Gross intake ratio(%) in Kyrgyz Republic?
Make the answer very short. 0.82. What is the difference between the highest and the second highest Gross intake ratio(%) in Myanmar?
Offer a terse response. 3.45. What is the difference between the highest and the lowest Gross intake ratio(%) of Fragile and conflict affected situations?
Provide a succinct answer. 19.82. What is the difference between the highest and the lowest Gross intake ratio(%) in Iran?
Provide a short and direct response. 8.65. What is the difference between the highest and the lowest Gross intake ratio(%) in Kyrgyz Republic?
Provide a short and direct response. 6.41. What is the difference between the highest and the lowest Gross intake ratio(%) in Myanmar?
Provide a short and direct response. 13.02. 